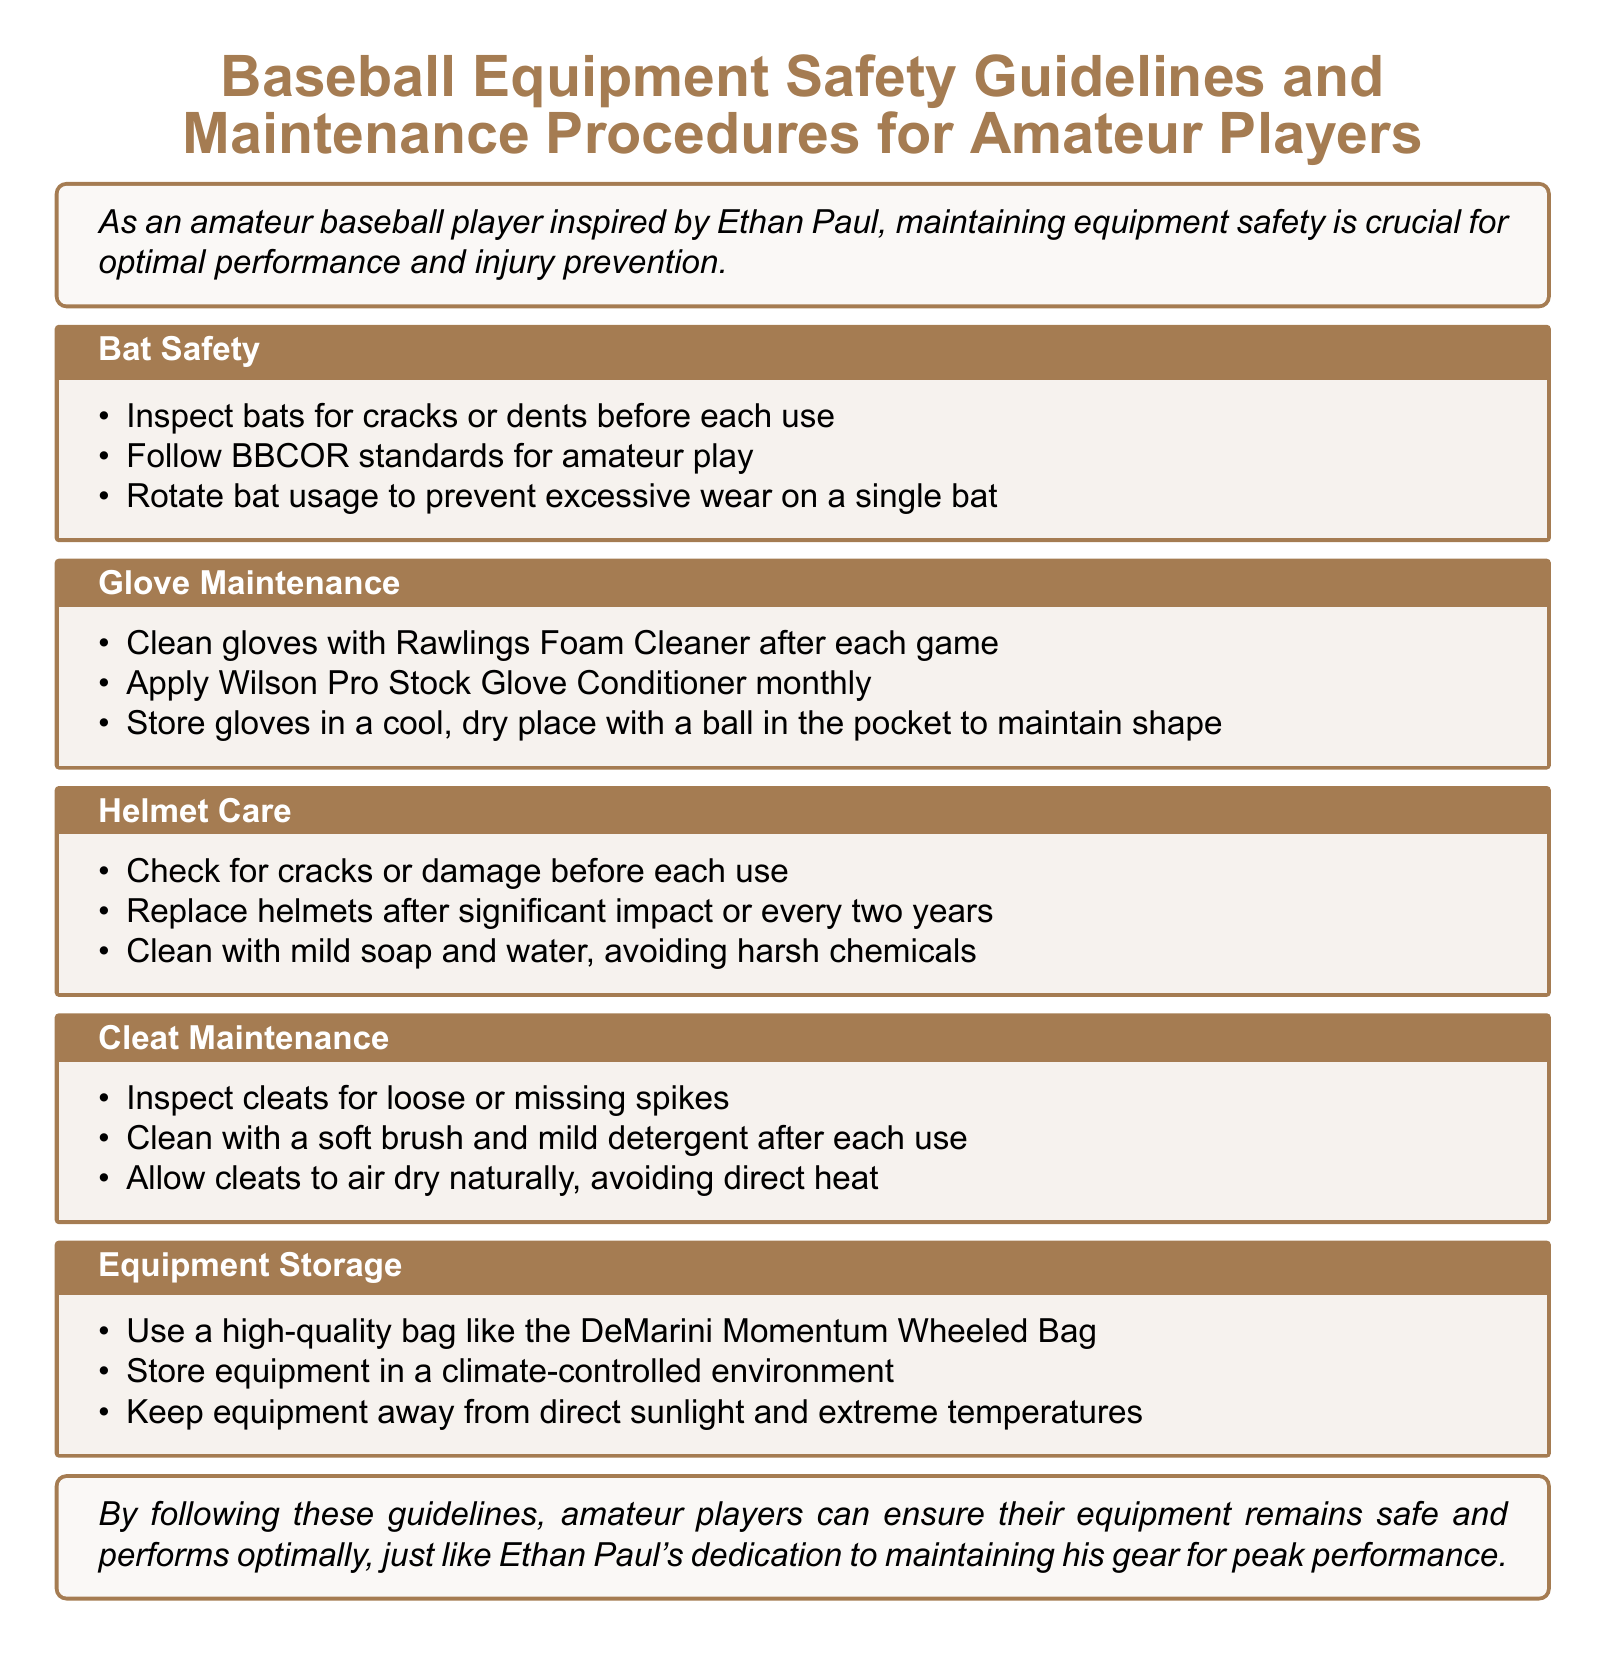What should you inspect before each use of a bat? The document specifies that you should inspect bats for cracks or dents before each use.
Answer: Cracks or dents What is the recommended product to clean gloves? The document mentions using Rawlings Foam Cleaner to clean gloves after each game.
Answer: Rawlings Foam Cleaner How often should you apply glove conditioner? The document states that you should apply Wilson Pro Stock Glove Conditioner monthly.
Answer: Monthly What should you do with a helmet after significant impact? The document advises replacing helmets after significant impact or every two years.
Answer: Replace What type of bag is recommended for storing equipment? The document recommends using the DeMarini Momentum Wheeled Bag for equipment storage.
Answer: DeMarini Momentum Wheeled Bag Why is it important to store equipment away from direct sunlight? The document indicates that keeping equipment away from direct sunlight helps protect it from extreme temperatures.
Answer: Protect from extreme temperatures What happens if you don't rotate bat usage? The document suggests that not rotating bat usage can lead to excessive wear on a single bat.
Answer: Excessive wear How should cleats be cleaned? The document advises cleaning cleats with a soft brush and mild detergent after each use.
Answer: Soft brush and mild detergent What is a good way to maintain glove shape when storing? The document suggests storing gloves with a ball in the pocket to maintain their shape.
Answer: Ball in the pocket 